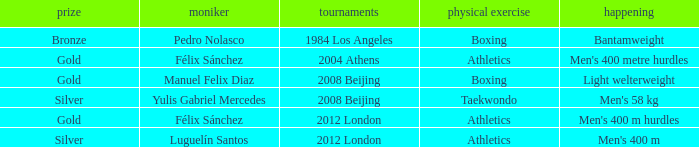Which Name had a Games of 2008 beijing, and a Medal of gold? Manuel Felix Diaz. 